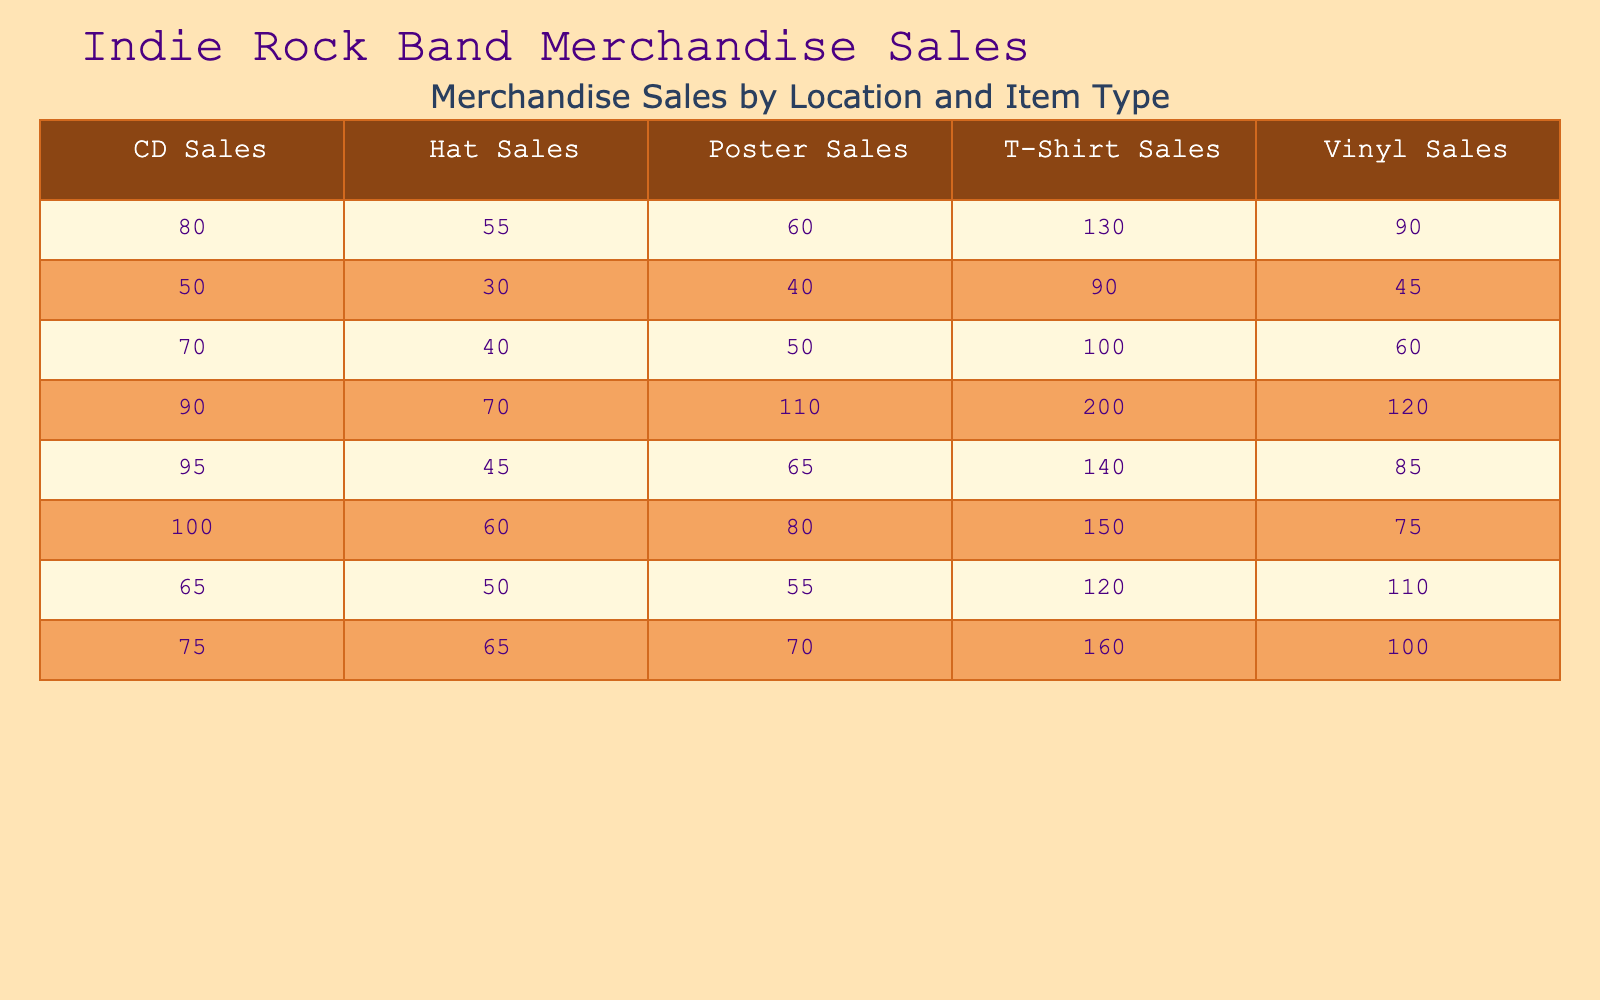What city had the highest T-Shirt sales? By examining the T-Shirt sales column, we see that Los Angeles has the highest value at 200.
Answer: Los Angeles What are the total sales of Vinyl in Chicago and Austin combined? In Chicago, Vinyl sales are 60, and in Austin, they are 90. Adding these together gives us 60 + 90 = 150.
Answer: 150 Is it true that Boston had more CD sales than poster sales? In Boston, CD sales are 50 while poster sales are 40. Since 50 is greater than 40, the statement is true.
Answer: Yes What is the average number of Hat sales across all concert locations? To find the average, sum the Hat sales (60 + 70 + 40 + 55 + 65 + 30 + 50 + 45) which equals 415. There are 8 locations, so the average is 415/8 = 51.875, rounding this gives us approximately 52.
Answer: 52 Which location had the least sales of Posters, and what was the number? Looking at the Poster sales column, we can see that Chicago had the least sales at 50.
Answer: Chicago, 50 What is the difference in T-Shirt sales between New York and Seattle? New York had 150 T-Shirts sold, while Seattle had 160. The difference is 160 - 150 = 10.
Answer: 10 Did Nashville sell more Vinyl than San Francisco? Nashville had 85 Vinyl sales and San Francisco had 110. Since 85 is less than 110, the statement is false.
Answer: No What are the total merchandise sales for Los Angeles? To find total sales for Los Angeles, we sum all item sales: 200 (T-Shirts) + 120 (Vinyl) + 90 (CDs) + 110 (Posters) + 70 (Hats) = 690.
Answer: 690 What percentage of total sales in Austin came from CD sales? In Austin, CD sales are 80. First, we find the total sales: 130 (T-Shirts) + 90 (Vinyl) + 80 (CDs) + 60 (Posters) + 55 (Hats) = 415. CD sales percentage is (80/415) * 100 = 19.28%, which rounds to approximately 19%.
Answer: 19% 